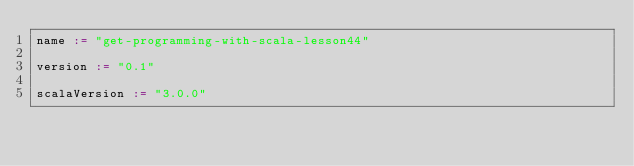Convert code to text. <code><loc_0><loc_0><loc_500><loc_500><_Scala_>name := "get-programming-with-scala-lesson44"

version := "0.1"

scalaVersion := "3.0.0"
</code> 